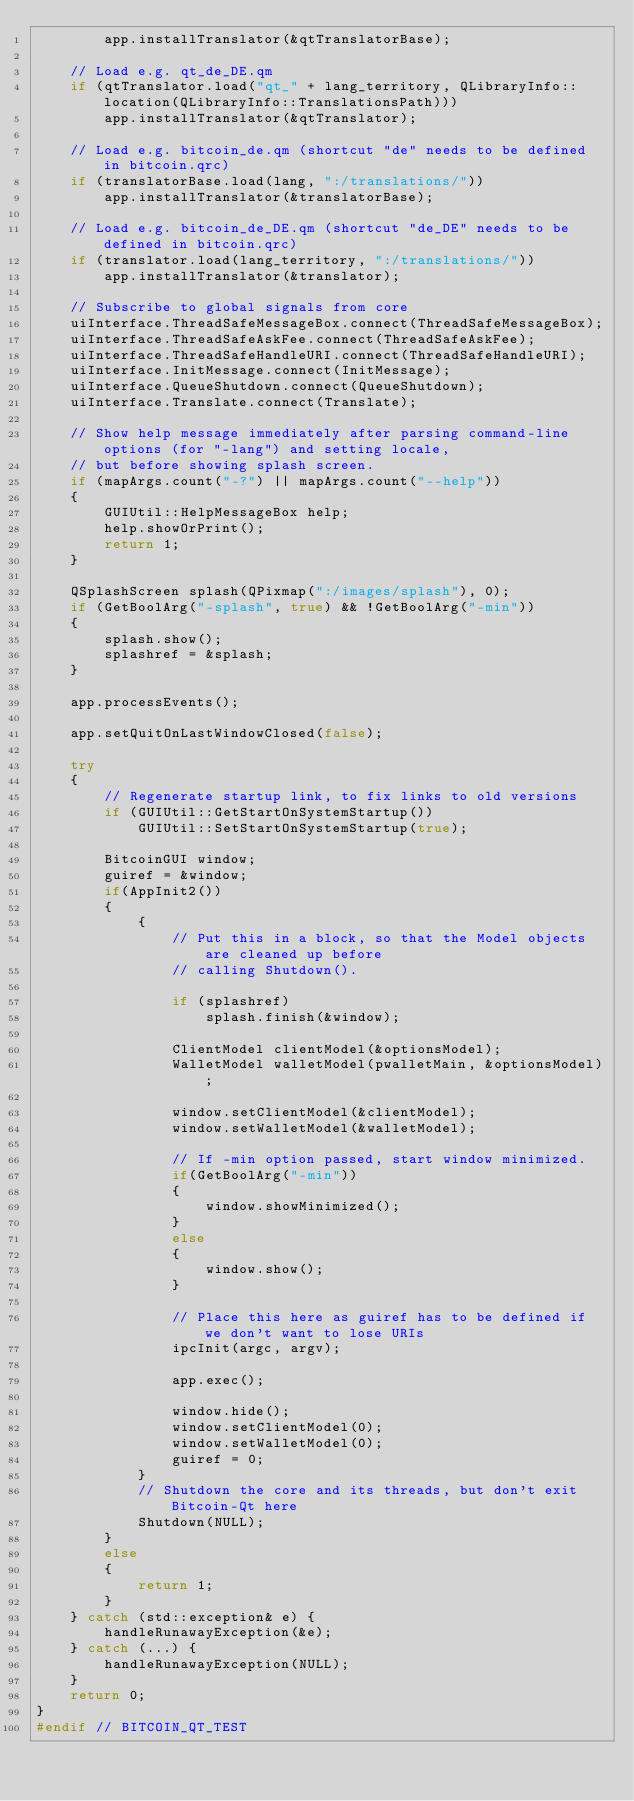Convert code to text. <code><loc_0><loc_0><loc_500><loc_500><_C++_>        app.installTranslator(&qtTranslatorBase);

    // Load e.g. qt_de_DE.qm
    if (qtTranslator.load("qt_" + lang_territory, QLibraryInfo::location(QLibraryInfo::TranslationsPath)))
        app.installTranslator(&qtTranslator);

    // Load e.g. bitcoin_de.qm (shortcut "de" needs to be defined in bitcoin.qrc)
    if (translatorBase.load(lang, ":/translations/"))
        app.installTranslator(&translatorBase);

    // Load e.g. bitcoin_de_DE.qm (shortcut "de_DE" needs to be defined in bitcoin.qrc)
    if (translator.load(lang_territory, ":/translations/"))
        app.installTranslator(&translator);

    // Subscribe to global signals from core
    uiInterface.ThreadSafeMessageBox.connect(ThreadSafeMessageBox);
    uiInterface.ThreadSafeAskFee.connect(ThreadSafeAskFee);
    uiInterface.ThreadSafeHandleURI.connect(ThreadSafeHandleURI);
    uiInterface.InitMessage.connect(InitMessage);
    uiInterface.QueueShutdown.connect(QueueShutdown);
    uiInterface.Translate.connect(Translate);

    // Show help message immediately after parsing command-line options (for "-lang") and setting locale,
    // but before showing splash screen.
    if (mapArgs.count("-?") || mapArgs.count("--help"))
    {
        GUIUtil::HelpMessageBox help;
        help.showOrPrint();
        return 1;
    }

    QSplashScreen splash(QPixmap(":/images/splash"), 0);
    if (GetBoolArg("-splash", true) && !GetBoolArg("-min"))
    {
        splash.show();
        splashref = &splash;
    }

    app.processEvents();

    app.setQuitOnLastWindowClosed(false);

    try
    {
        // Regenerate startup link, to fix links to old versions
        if (GUIUtil::GetStartOnSystemStartup())
            GUIUtil::SetStartOnSystemStartup(true);

        BitcoinGUI window;
        guiref = &window;
        if(AppInit2())
        {
            {
                // Put this in a block, so that the Model objects are cleaned up before
                // calling Shutdown().

                if (splashref)
                    splash.finish(&window);

                ClientModel clientModel(&optionsModel);
                WalletModel walletModel(pwalletMain, &optionsModel);

                window.setClientModel(&clientModel);
                window.setWalletModel(&walletModel);

                // If -min option passed, start window minimized.
                if(GetBoolArg("-min"))
                {
                    window.showMinimized();
                }
                else
                {
                    window.show();
                }

                // Place this here as guiref has to be defined if we don't want to lose URIs
                ipcInit(argc, argv);

                app.exec();

                window.hide();
                window.setClientModel(0);
                window.setWalletModel(0);
                guiref = 0;
            }
            // Shutdown the core and its threads, but don't exit Bitcoin-Qt here
            Shutdown(NULL);
        }
        else
        {
            return 1;
        }
    } catch (std::exception& e) {
        handleRunawayException(&e);
    } catch (...) {
        handleRunawayException(NULL);
    }
    return 0;
}
#endif // BITCOIN_QT_TEST
</code> 